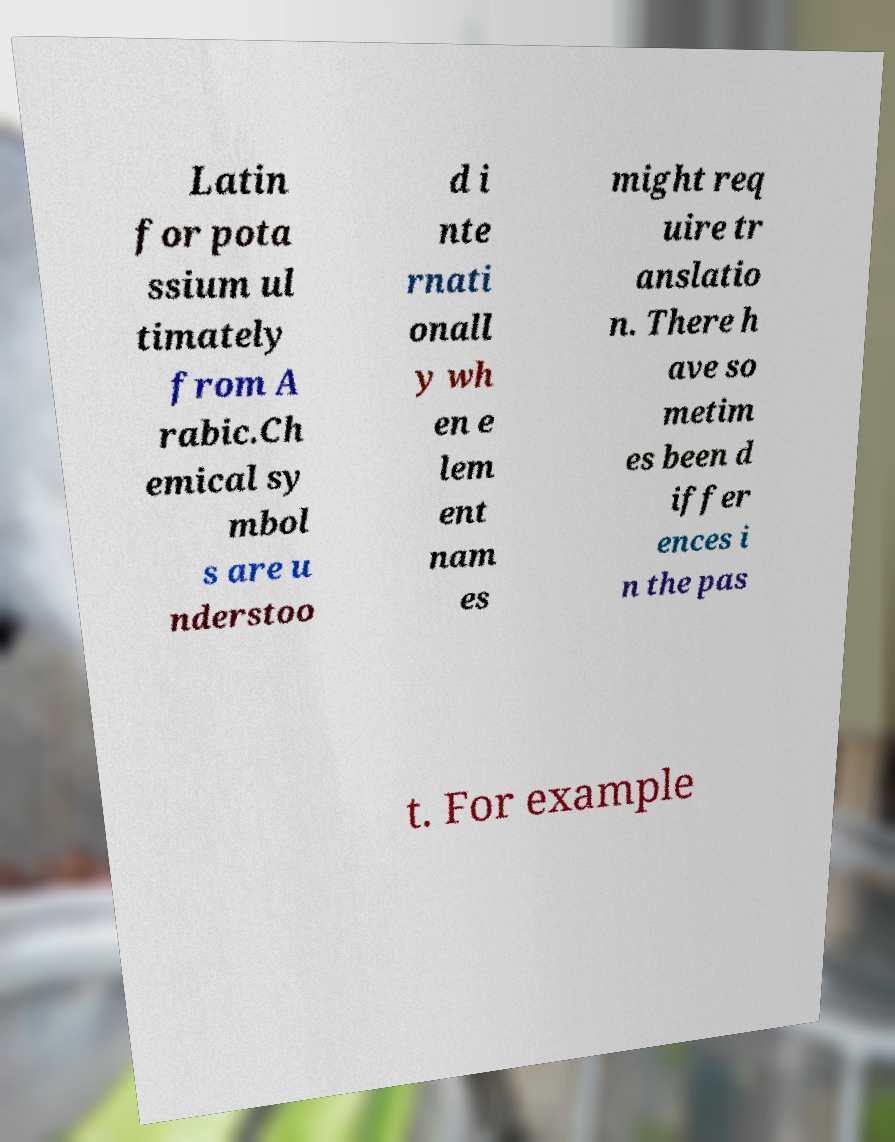Please identify and transcribe the text found in this image. Latin for pota ssium ul timately from A rabic.Ch emical sy mbol s are u nderstoo d i nte rnati onall y wh en e lem ent nam es might req uire tr anslatio n. There h ave so metim es been d iffer ences i n the pas t. For example 